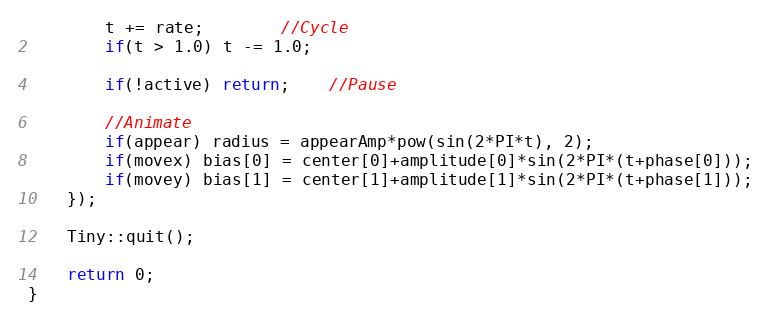Convert code to text. <code><loc_0><loc_0><loc_500><loc_500><_C++_>		t += rate;		//Cycle
		if(t > 1.0) t -= 1.0;

		if(!active) return;	//Pause

		//Animate
		if(appear) radius = appearAmp*pow(sin(2*PI*t), 2);
		if(movex) bias[0] = center[0]+amplitude[0]*sin(2*PI*(t+phase[0]));
		if(movey) bias[1] = center[1]+amplitude[1]*sin(2*PI*(t+phase[1]));
	});

	Tiny::quit();

	return 0;
}
</code> 